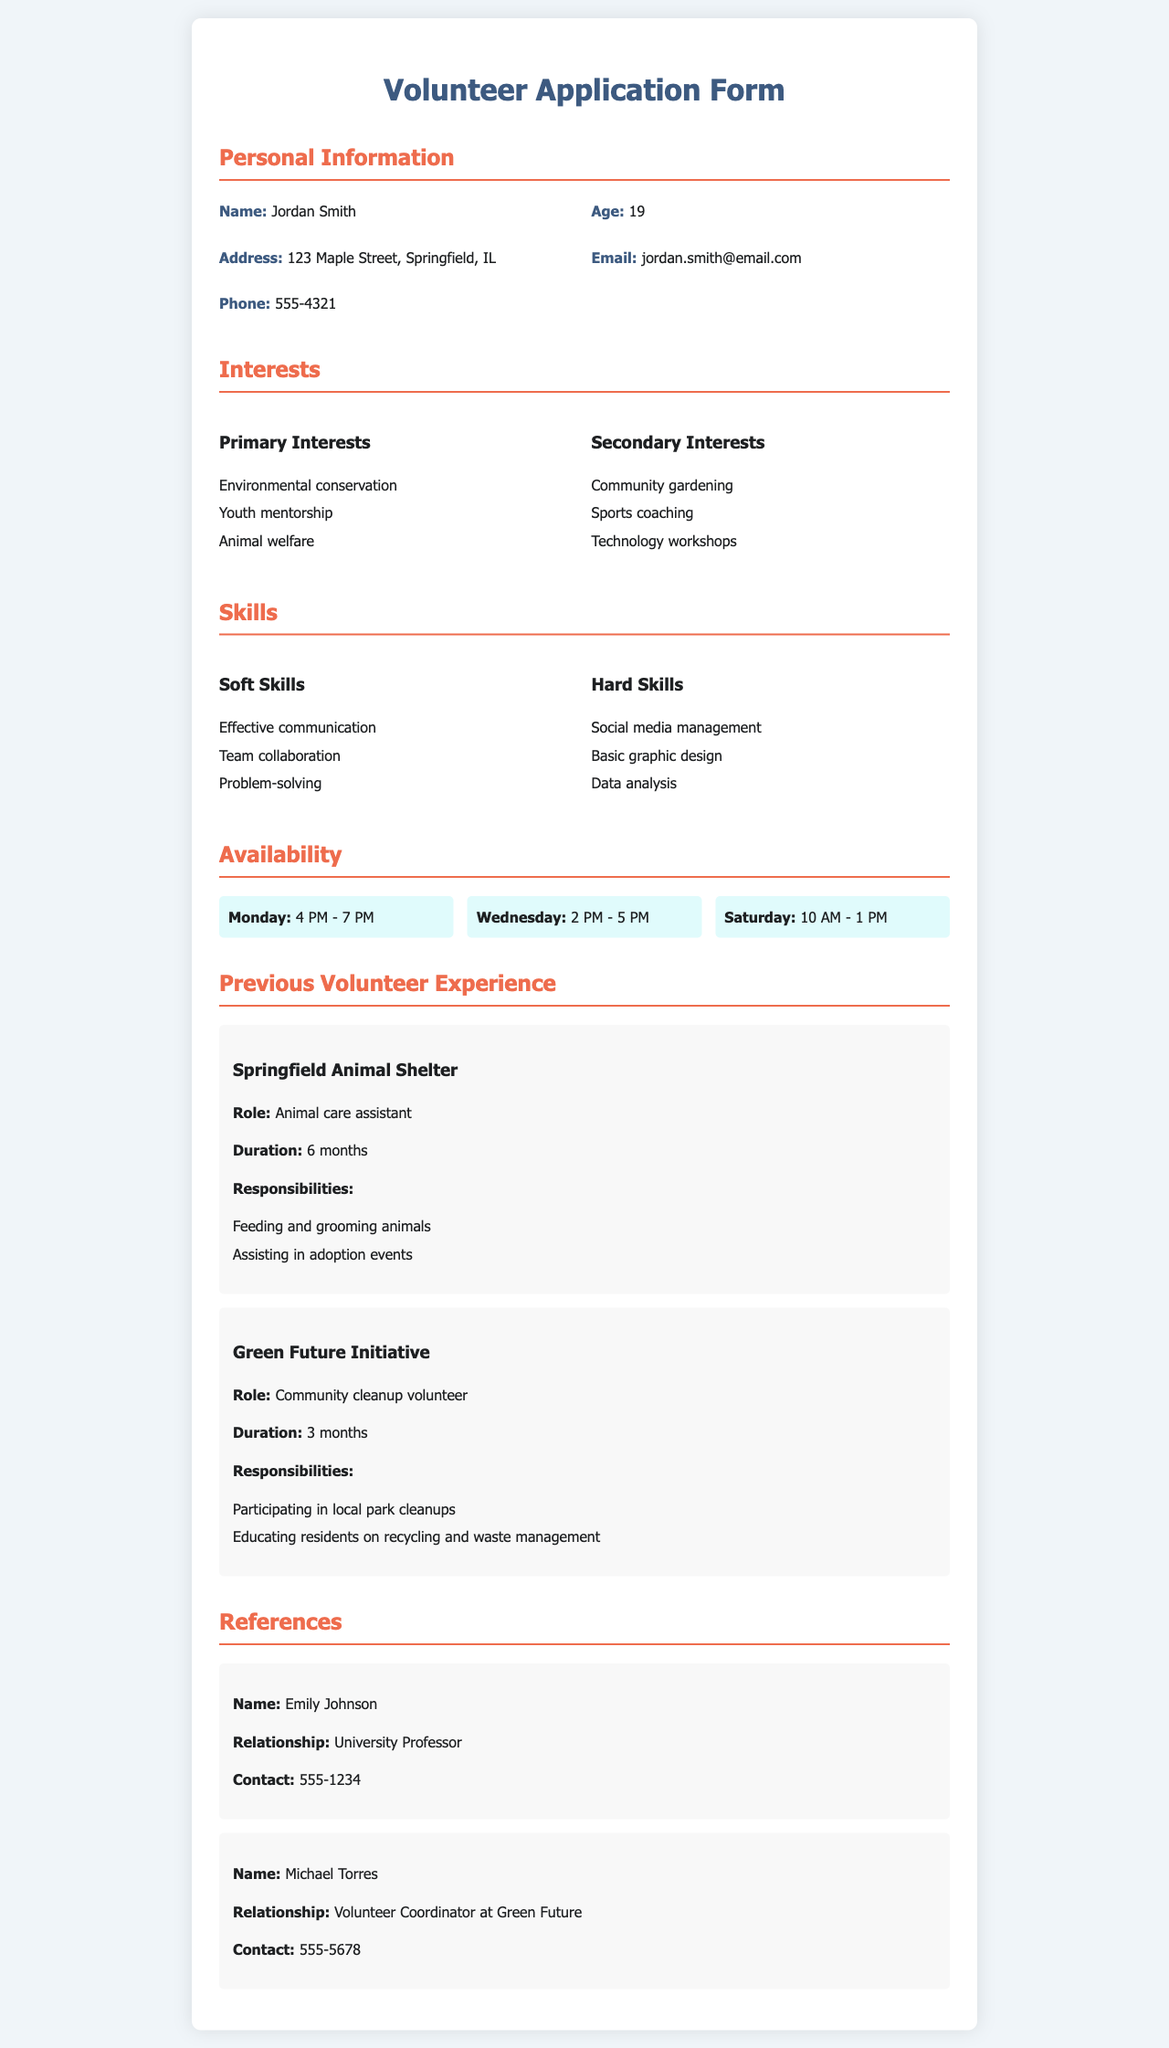What is the applicant's name? The name of the applicant is provided in the personal information section of the document.
Answer: Jordan Smith What are the primary interests listed? The primary interests are listed under the interests section of the document.
Answer: Environmental conservation, Youth mentorship, Animal welfare What is the age of the applicant? The age of the applicant is stated in the personal information section of the document.
Answer: 19 On which day is the applicant available from 2 PM to 5 PM? The availability section of the document specifies which days the applicant is free during these hours.
Answer: Wednesday What role did the applicant serve at the Springfield Animal Shelter? The role of the applicant is mentioned in the previous volunteer experience section.
Answer: Animal care assistant How many months did the applicant volunteer at the Green Future Initiative? The duration of volunteering at this initiative is provided in the volunteer experience section.
Answer: 3 months Who is listed as a reference? The reference section contains names of individuals who can speak to the applicant's qualifications.
Answer: Emily Johnson What is one of the hard skills mentioned? Hard skills listed in the skills section of the document can provide insight into the applicant’s capabilities.
Answer: Social media management What time is the earliest the applicant is available on Saturday? The availability section indicates the time slots the applicant is free on Saturday.
Answer: 10 AM 